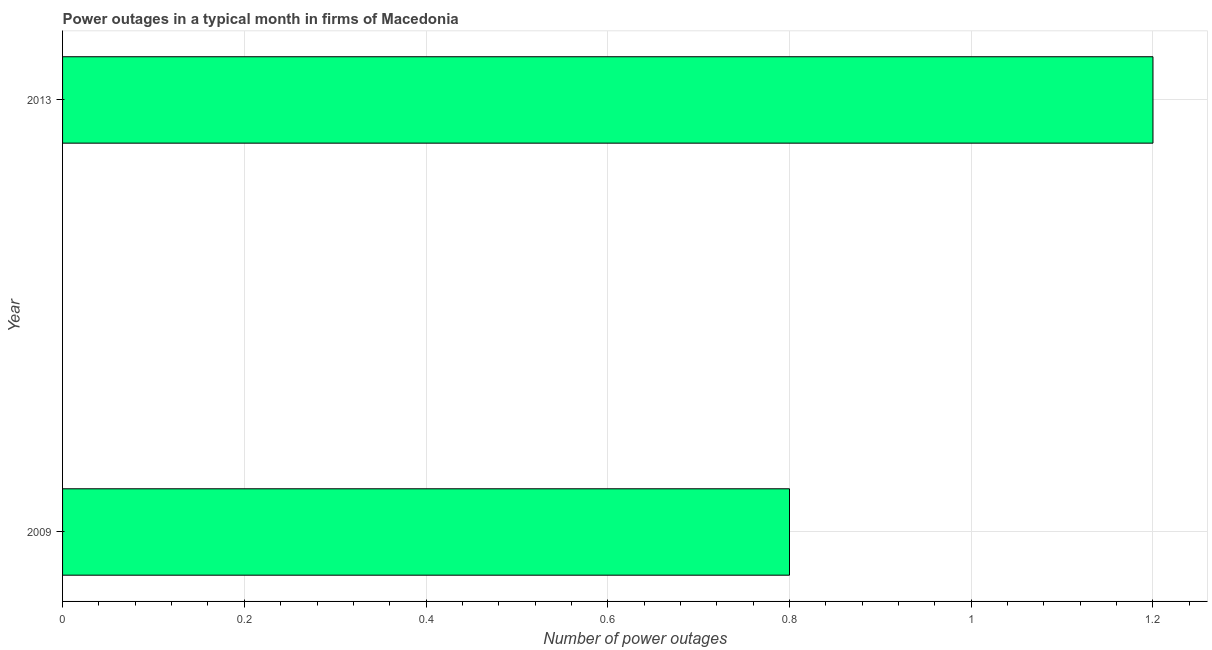What is the title of the graph?
Provide a short and direct response. Power outages in a typical month in firms of Macedonia. What is the label or title of the X-axis?
Offer a very short reply. Number of power outages. What is the number of power outages in 2013?
Keep it short and to the point. 1.2. Across all years, what is the maximum number of power outages?
Keep it short and to the point. 1.2. In which year was the number of power outages maximum?
Ensure brevity in your answer.  2013. What is the sum of the number of power outages?
Keep it short and to the point. 2. What is the difference between the number of power outages in 2009 and 2013?
Offer a terse response. -0.4. What is the average number of power outages per year?
Provide a short and direct response. 1. What is the median number of power outages?
Offer a terse response. 1. Do a majority of the years between 2009 and 2013 (inclusive) have number of power outages greater than 0.68 ?
Offer a very short reply. Yes. What is the ratio of the number of power outages in 2009 to that in 2013?
Provide a succinct answer. 0.67. Is the number of power outages in 2009 less than that in 2013?
Your answer should be very brief. Yes. What is the difference between two consecutive major ticks on the X-axis?
Your answer should be very brief. 0.2. Are the values on the major ticks of X-axis written in scientific E-notation?
Give a very brief answer. No. What is the ratio of the Number of power outages in 2009 to that in 2013?
Give a very brief answer. 0.67. 